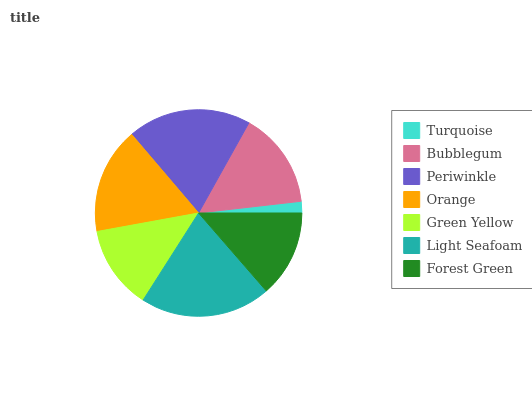Is Turquoise the minimum?
Answer yes or no. Yes. Is Light Seafoam the maximum?
Answer yes or no. Yes. Is Bubblegum the minimum?
Answer yes or no. No. Is Bubblegum the maximum?
Answer yes or no. No. Is Bubblegum greater than Turquoise?
Answer yes or no. Yes. Is Turquoise less than Bubblegum?
Answer yes or no. Yes. Is Turquoise greater than Bubblegum?
Answer yes or no. No. Is Bubblegum less than Turquoise?
Answer yes or no. No. Is Bubblegum the high median?
Answer yes or no. Yes. Is Bubblegum the low median?
Answer yes or no. Yes. Is Turquoise the high median?
Answer yes or no. No. Is Green Yellow the low median?
Answer yes or no. No. 